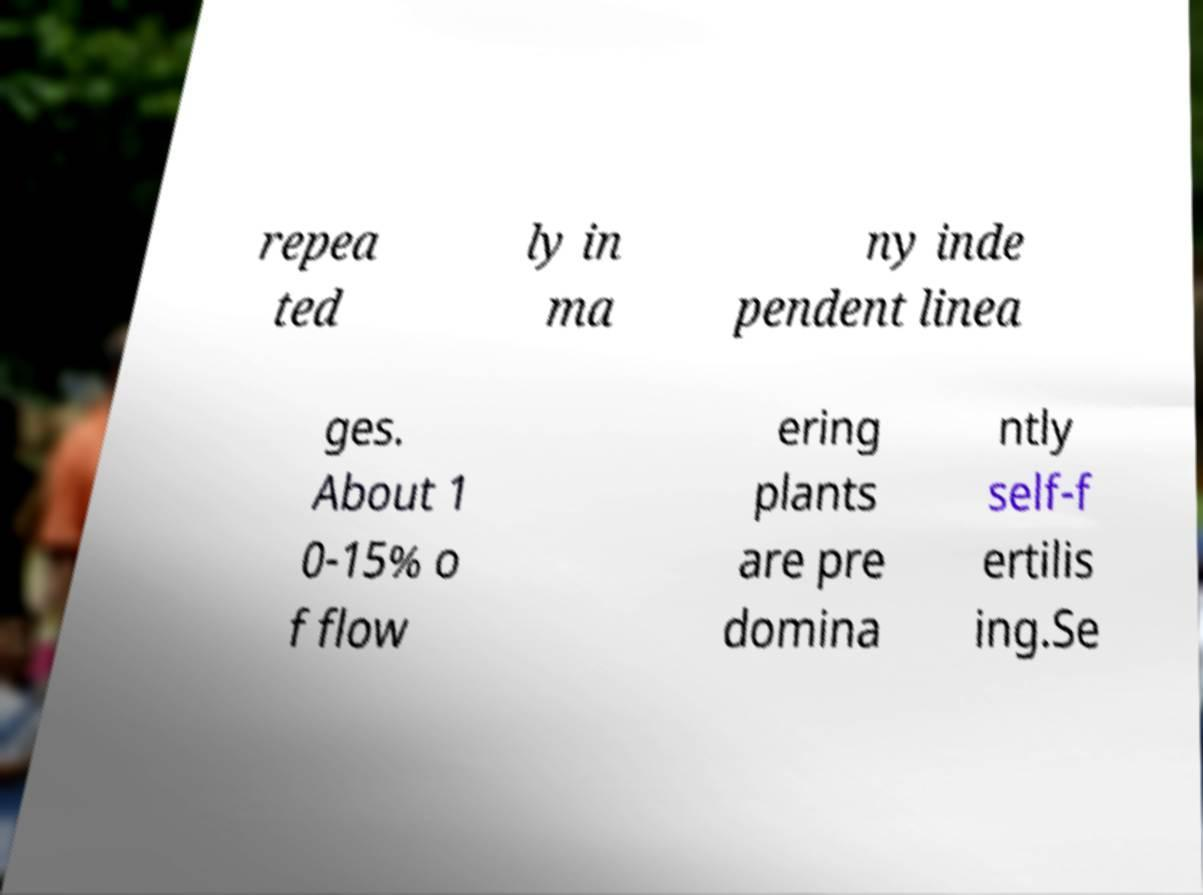I need the written content from this picture converted into text. Can you do that? repea ted ly in ma ny inde pendent linea ges. About 1 0-15% o f flow ering plants are pre domina ntly self-f ertilis ing.Se 